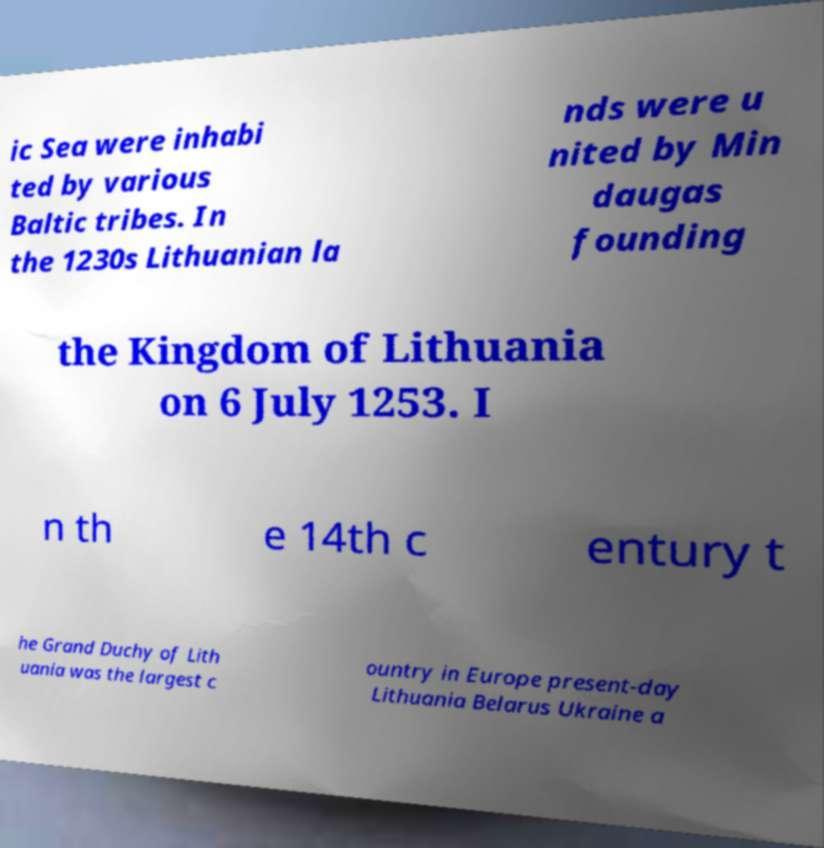There's text embedded in this image that I need extracted. Can you transcribe it verbatim? ic Sea were inhabi ted by various Baltic tribes. In the 1230s Lithuanian la nds were u nited by Min daugas founding the Kingdom of Lithuania on 6 July 1253. I n th e 14th c entury t he Grand Duchy of Lith uania was the largest c ountry in Europe present-day Lithuania Belarus Ukraine a 